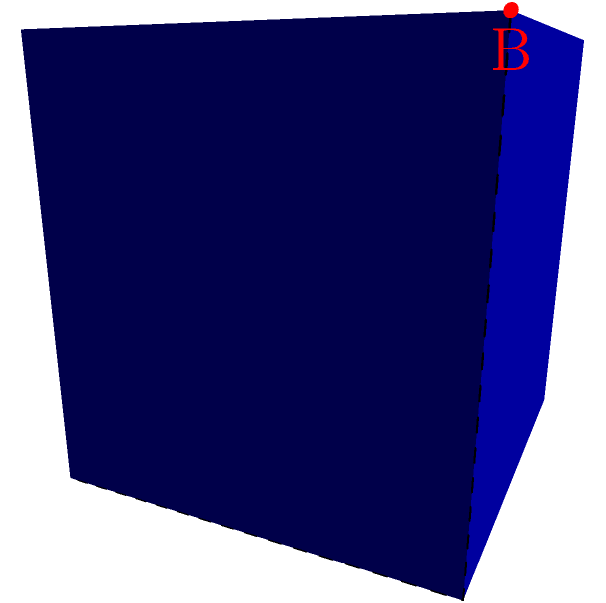In a 3D coordinate system, a robotic arm needs to move from point A (0,0,0) to point B (1,1,1). Two possible paths are considered: a direct diagonal path and a path along the edges of the cube. Given that the arm's speed is constant and the cost of movement is directly proportional to the distance traveled, which path is more efficient, and by what percentage? To determine the most efficient path, we need to calculate and compare the lengths of both paths:

1. Direct diagonal path:
   The length of this path is the distance between two points in 3D space.
   Using the distance formula: $d = \sqrt{(x_2-x_1)^2 + (y_2-y_1)^2 + (z_2-z_1)^2}$
   $d = \sqrt{(1-0)^2 + (1-0)^2 + (1-0)^2} = \sqrt{3} \approx 1.732$

2. Path along the edges:
   This path consists of three unit-length segments: (0,0,0) to (1,0,0), (1,0,0) to (1,1,0), and (1,1,0) to (1,1,1).
   Total length = 1 + 1 + 1 = 3

3. Efficiency comparison:
   The direct path is shorter, thus more efficient.
   Efficiency gain = $\frac{\text{Longer path} - \text{Shorter path}}{\text{Longer path}} \times 100\%$
   $= \frac{3 - \sqrt{3}}{3} \times 100\% \approx 42.26\%$

Therefore, the diagonal path is approximately 42.26% more efficient than the path along the edges.
Answer: Diagonal path; 42.26% more efficient 